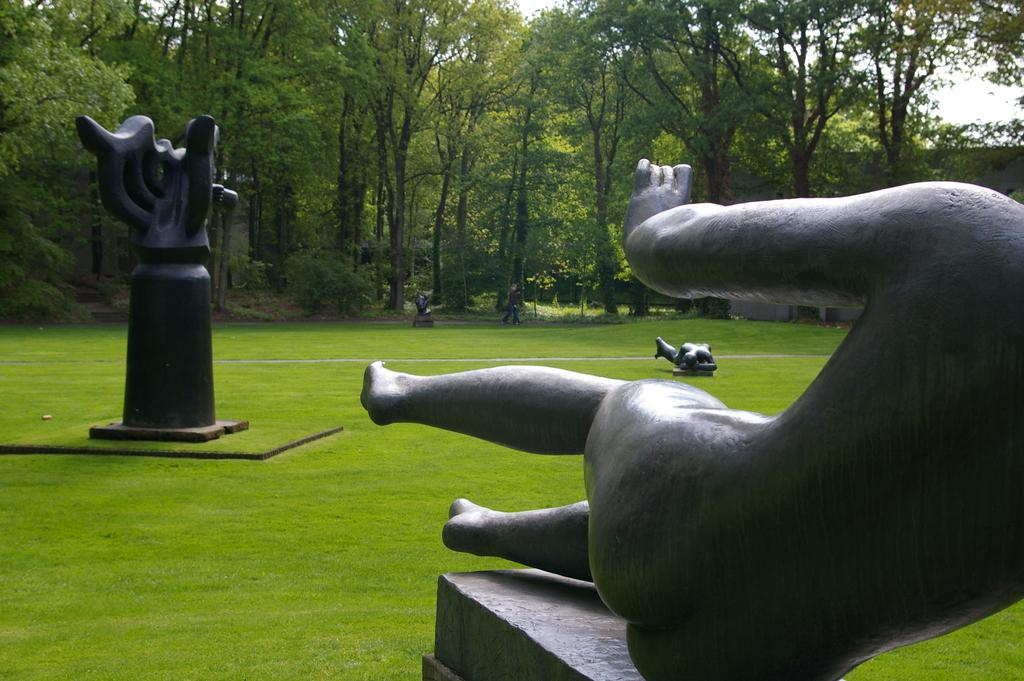What type of vegetation is present in the image? There is grass in the image. What type of structures can be seen in the image? There are statues and a wall in the image. What type of natural elements are present in the image? There are trees in the image. Who or what is present in the image? There is a person in the image. What is visible in the background of the image? The sky is visible in the background of the image. What type of underwear is the person wearing in the image? There is no information about the person's underwear in the image, and therefore it cannot be determined. Is there a road visible in the image? No, there is no road present in the image. 